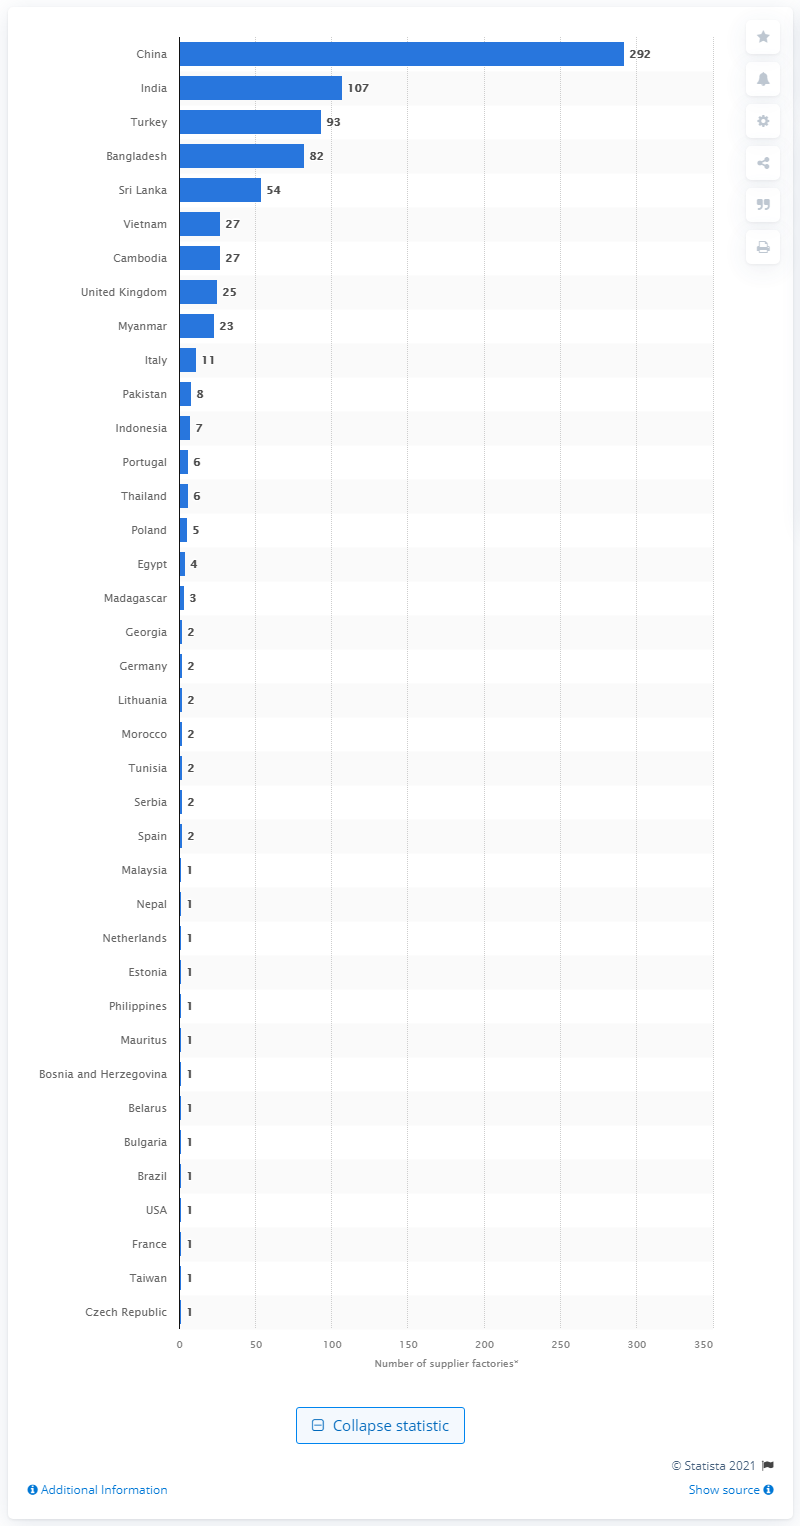Point out several critical features in this image. As of June 2021, India had 107 factories. As of June 2021, Marks & Spencer had 292 factories in China. 